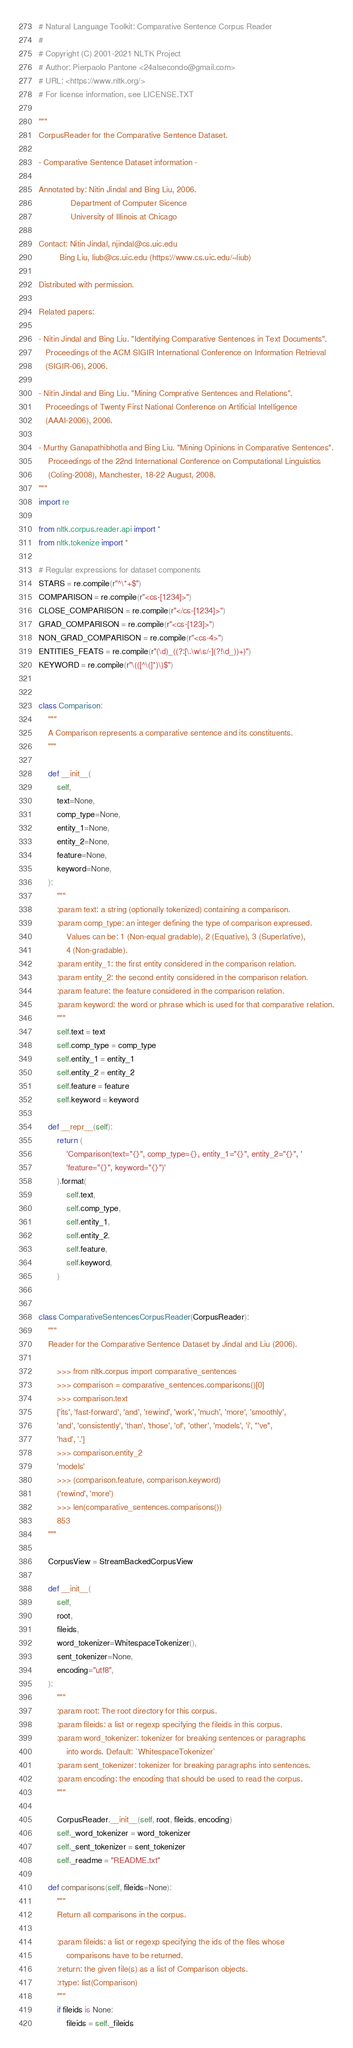<code> <loc_0><loc_0><loc_500><loc_500><_Python_># Natural Language Toolkit: Comparative Sentence Corpus Reader
#
# Copyright (C) 2001-2021 NLTK Project
# Author: Pierpaolo Pantone <24alsecondo@gmail.com>
# URL: <https://www.nltk.org/>
# For license information, see LICENSE.TXT

"""
CorpusReader for the Comparative Sentence Dataset.

- Comparative Sentence Dataset information -

Annotated by: Nitin Jindal and Bing Liu, 2006.
              Department of Computer Sicence
              University of Illinois at Chicago

Contact: Nitin Jindal, njindal@cs.uic.edu
         Bing Liu, liub@cs.uic.edu (https://www.cs.uic.edu/~liub)

Distributed with permission.

Related papers:

- Nitin Jindal and Bing Liu. "Identifying Comparative Sentences in Text Documents".
   Proceedings of the ACM SIGIR International Conference on Information Retrieval
   (SIGIR-06), 2006.

- Nitin Jindal and Bing Liu. "Mining Comprative Sentences and Relations".
   Proceedings of Twenty First National Conference on Artificial Intelligence
   (AAAI-2006), 2006.

- Murthy Ganapathibhotla and Bing Liu. "Mining Opinions in Comparative Sentences".
    Proceedings of the 22nd International Conference on Computational Linguistics
    (Coling-2008), Manchester, 18-22 August, 2008.
"""
import re

from nltk.corpus.reader.api import *
from nltk.tokenize import *

# Regular expressions for dataset components
STARS = re.compile(r"^\*+$")
COMPARISON = re.compile(r"<cs-[1234]>")
CLOSE_COMPARISON = re.compile(r"</cs-[1234]>")
GRAD_COMPARISON = re.compile(r"<cs-[123]>")
NON_GRAD_COMPARISON = re.compile(r"<cs-4>")
ENTITIES_FEATS = re.compile(r"(\d)_((?:[\.\w\s/-](?!\d_))+)")
KEYWORD = re.compile(r"\(([^\(]*)\)$")


class Comparison:
    """
    A Comparison represents a comparative sentence and its constituents.
    """

    def __init__(
        self,
        text=None,
        comp_type=None,
        entity_1=None,
        entity_2=None,
        feature=None,
        keyword=None,
    ):
        """
        :param text: a string (optionally tokenized) containing a comparison.
        :param comp_type: an integer defining the type of comparison expressed.
            Values can be: 1 (Non-equal gradable), 2 (Equative), 3 (Superlative),
            4 (Non-gradable).
        :param entity_1: the first entity considered in the comparison relation.
        :param entity_2: the second entity considered in the comparison relation.
        :param feature: the feature considered in the comparison relation.
        :param keyword: the word or phrase which is used for that comparative relation.
        """
        self.text = text
        self.comp_type = comp_type
        self.entity_1 = entity_1
        self.entity_2 = entity_2
        self.feature = feature
        self.keyword = keyword

    def __repr__(self):
        return (
            'Comparison(text="{}", comp_type={}, entity_1="{}", entity_2="{}", '
            'feature="{}", keyword="{}")'
        ).format(
            self.text,
            self.comp_type,
            self.entity_1,
            self.entity_2,
            self.feature,
            self.keyword,
        )


class ComparativeSentencesCorpusReader(CorpusReader):
    """
    Reader for the Comparative Sentence Dataset by Jindal and Liu (2006).

        >>> from nltk.corpus import comparative_sentences
        >>> comparison = comparative_sentences.comparisons()[0]
        >>> comparison.text
        ['its', 'fast-forward', 'and', 'rewind', 'work', 'much', 'more', 'smoothly',
        'and', 'consistently', 'than', 'those', 'of', 'other', 'models', 'i', "'ve",
        'had', '.']
        >>> comparison.entity_2
        'models'
        >>> (comparison.feature, comparison.keyword)
        ('rewind', 'more')
        >>> len(comparative_sentences.comparisons())
        853
    """

    CorpusView = StreamBackedCorpusView

    def __init__(
        self,
        root,
        fileids,
        word_tokenizer=WhitespaceTokenizer(),
        sent_tokenizer=None,
        encoding="utf8",
    ):
        """
        :param root: The root directory for this corpus.
        :param fileids: a list or regexp specifying the fileids in this corpus.
        :param word_tokenizer: tokenizer for breaking sentences or paragraphs
            into words. Default: `WhitespaceTokenizer`
        :param sent_tokenizer: tokenizer for breaking paragraphs into sentences.
        :param encoding: the encoding that should be used to read the corpus.
        """

        CorpusReader.__init__(self, root, fileids, encoding)
        self._word_tokenizer = word_tokenizer
        self._sent_tokenizer = sent_tokenizer
        self._readme = "README.txt"

    def comparisons(self, fileids=None):
        """
        Return all comparisons in the corpus.

        :param fileids: a list or regexp specifying the ids of the files whose
            comparisons have to be returned.
        :return: the given file(s) as a list of Comparison objects.
        :rtype: list(Comparison)
        """
        if fileids is None:
            fileids = self._fileids</code> 